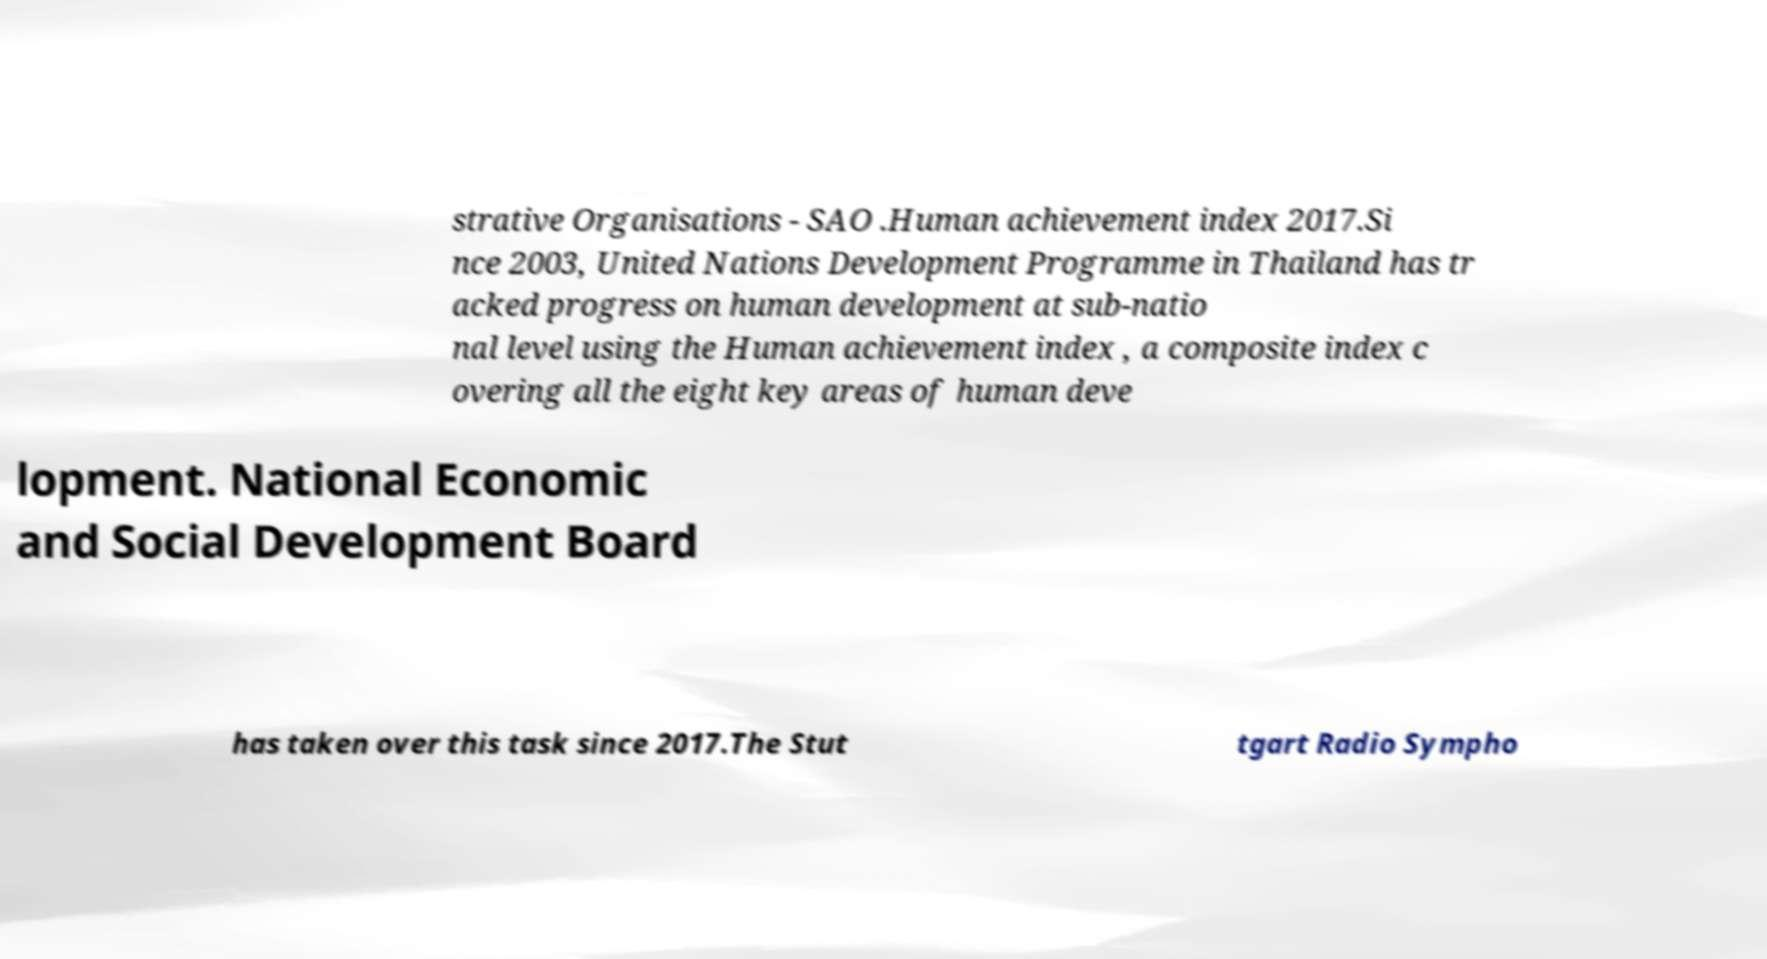Can you accurately transcribe the text from the provided image for me? strative Organisations - SAO .Human achievement index 2017.Si nce 2003, United Nations Development Programme in Thailand has tr acked progress on human development at sub-natio nal level using the Human achievement index , a composite index c overing all the eight key areas of human deve lopment. National Economic and Social Development Board has taken over this task since 2017.The Stut tgart Radio Sympho 